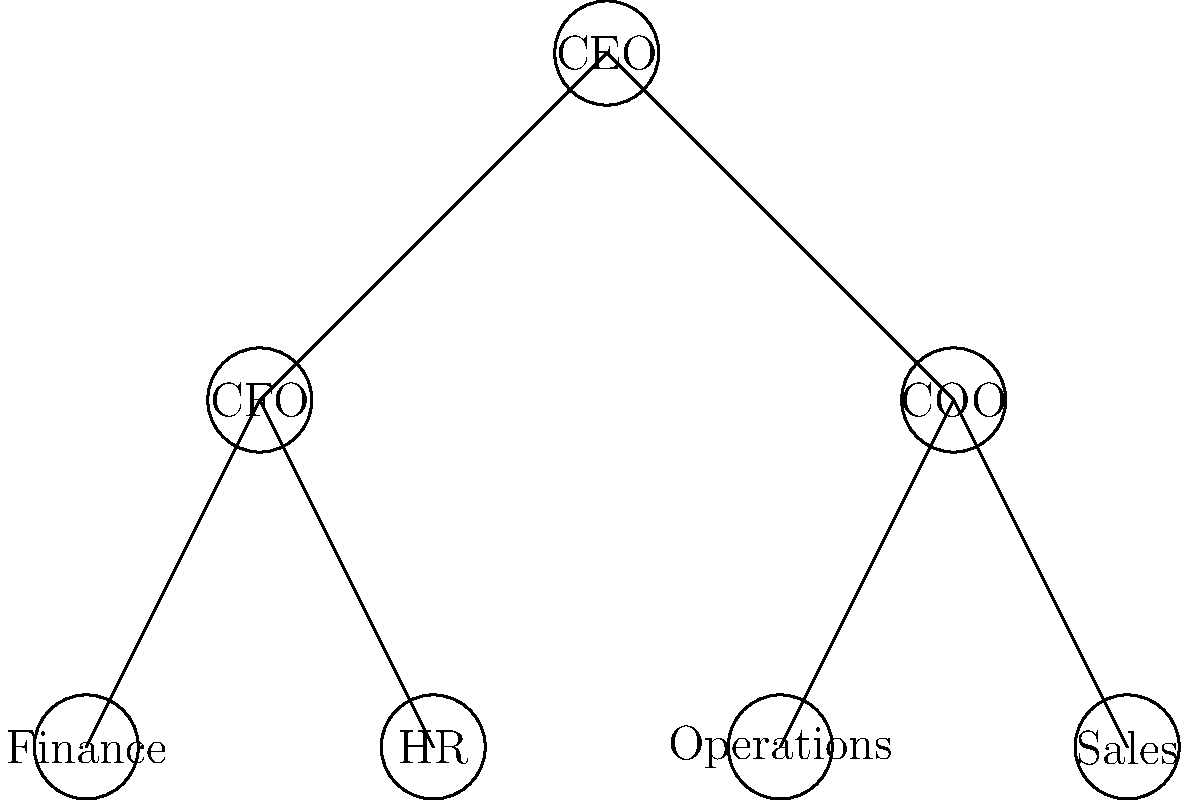As the executive at Envisage Group, you're reviewing the organizational chart. How many departments report directly to the COO? To answer this question, we need to follow these steps:

1. Identify the COO (Chief Operating Officer) in the organizational chart.
   - The COO is on the right side of the second level of the chart.

2. Count the number of departments directly connected to the COO.
   - We can see two lines extending downward from the COO.
   - These lines connect to "Operations" and "Sales" departments.

3. Count the total number of departments reporting to the COO.
   - Operations department: 1
   - Sales department: 1
   - Total: 1 + 1 = 2 departments

Therefore, there are 2 departments reporting directly to the COO.
Answer: 2 departments 